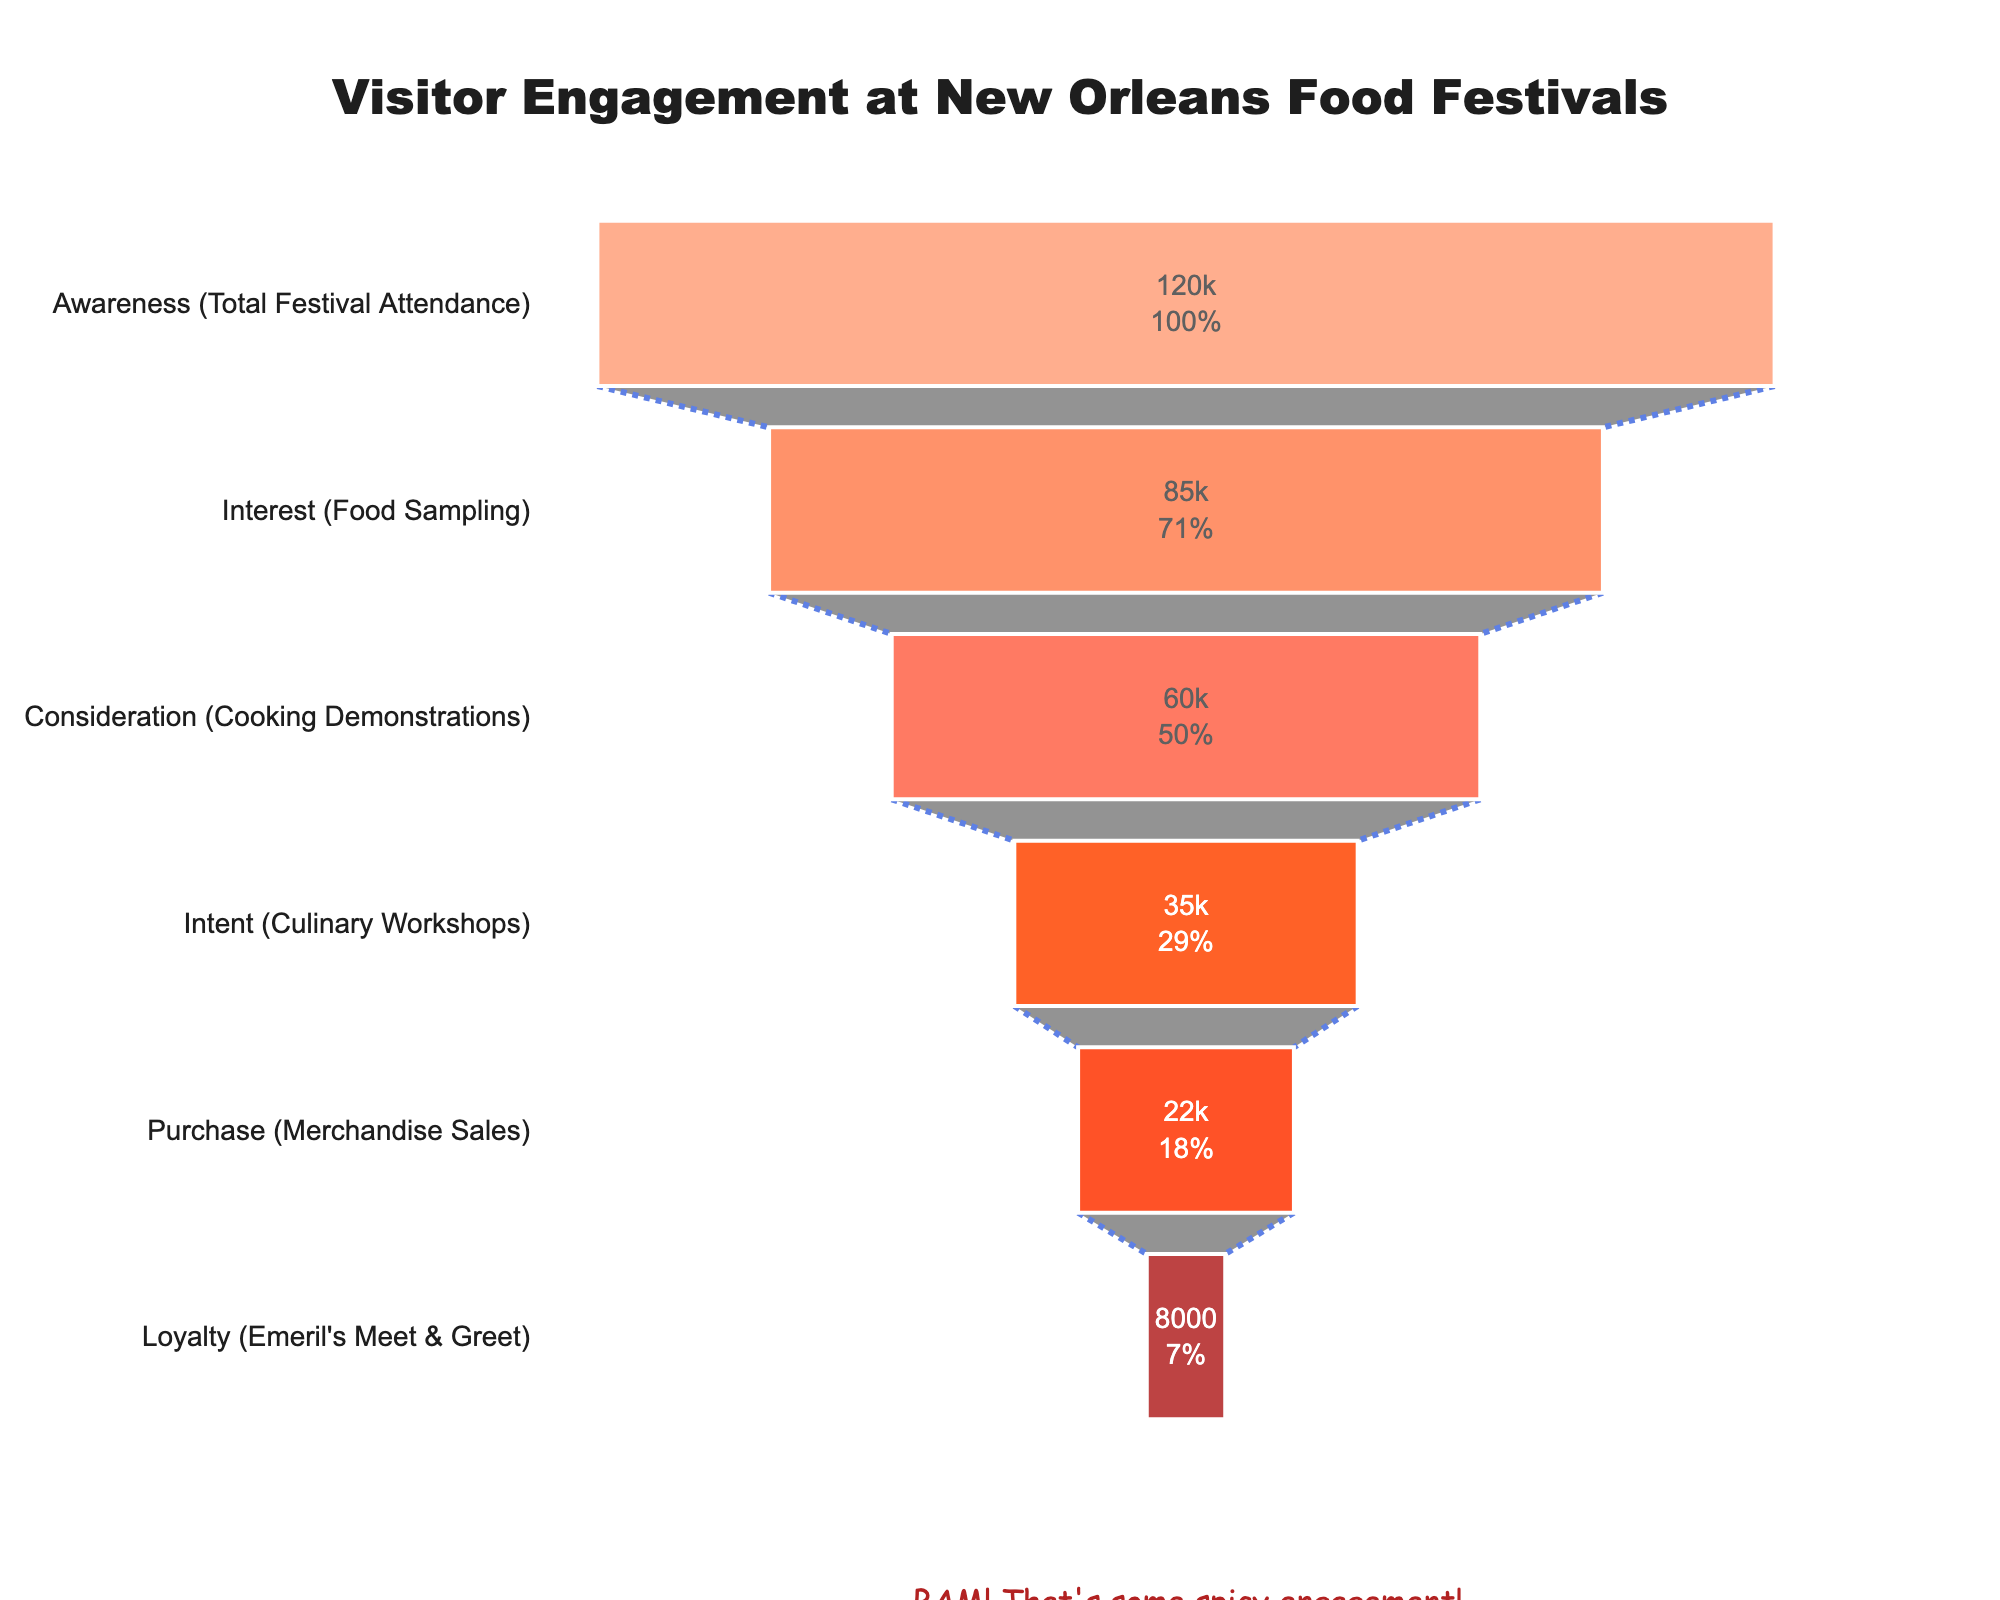What's the title of the figure? The title is prominently displayed at the top of the figure. It helps provide context and summarizes the focus of the chart.
Answer: Visitor Engagement at New Orleans Food Festivals How many stages are presented in the funnel chart? By counting the distinct segments or levels in the funnel chart, we can determine the number of stages.
Answer: Six Which engagement stage has the most visitors? By observing the width of the segments and referring to the values, we can identify the stage with the maximum visitor count.
Answer: Awareness (Total Festival Attendance) What percentage of total attendees participate in the food sampling stage? The funnel chart shows both the absolute numbers and the percent initial value within each segment. For the food sampling stage, we use this visible data.
Answer: Approximately 70.8% How many more visitors attend cooking demonstrations compared to culinary workshops? We need to subtract the number of visitors of culinary workshops from the cooking demonstrations: 60000 - 35000.
Answer: 25000 What stage has the least visitor engagement? The smallest width in the funnel chart represents the lowest engagement level, as indicated by the values provided.
Answer: Loyalty (Emeril's Meet & Greet) What is the total number of visitors from consideration to loyalty? We sum the visitor numbers provided for the stages from consideration to loyalty: 60000 + 35000 + 22000 + 8000.
Answer: 125000 Which two stages have the largest drop in visitor numbers? Observing the funnel, the largest drop can be detected by comparing the visitor numbers between adjacent stages. The largest numerical difference gives the answer.
Answer: Interest to Consideration (25000 visitors) How does the percentage of visitors purchasing merchandise compare to those attending demonstrations? Calculate the percentage for each stage (22000/120000 for merchandise sales, 60000/120000 for cooking demonstrations), compare these values to determine the difference.
Answer: Approximately 18.3% less What is the difference in participation between food sampling and interest in cooking demonstrations? Subtract the number of visitors for cooking demonstrations from the visitors for food sampling: 85000 - 60000.
Answer: 25000 